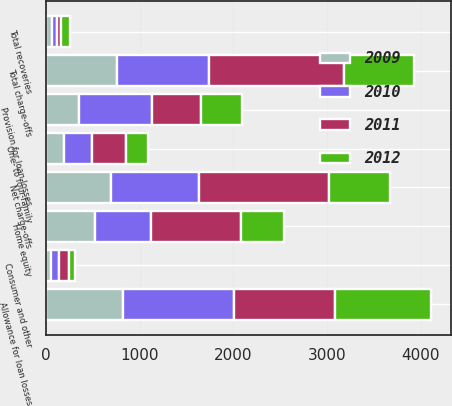<chart> <loc_0><loc_0><loc_500><loc_500><stacked_bar_chart><ecel><fcel>Allowance for loan losses<fcel>Provision for loan losses<fcel>One- to four-family<fcel>Home equity<fcel>Consumer and other<fcel>Total charge-offs<fcel>Total recoveries<fcel>Net charge-offs<nl><fcel>2009<fcel>822.8<fcel>354.6<fcel>189.9<fcel>517.2<fcel>51.1<fcel>758.2<fcel>61.5<fcel>696.7<nl><fcel>2012<fcel>1031.2<fcel>440.6<fcel>228.9<fcel>457.3<fcel>59.3<fcel>745.5<fcel>96.5<fcel>649<nl><fcel>2010<fcel>1182.7<fcel>779.4<fcel>302.6<fcel>600<fcel>80.3<fcel>982.9<fcel>52<fcel>930.9<nl><fcel>2011<fcel>1080.6<fcel>517.2<fcel>364.3<fcel>966.3<fcel>111.6<fcel>1442.2<fcel>46.2<fcel>1396<nl></chart> 